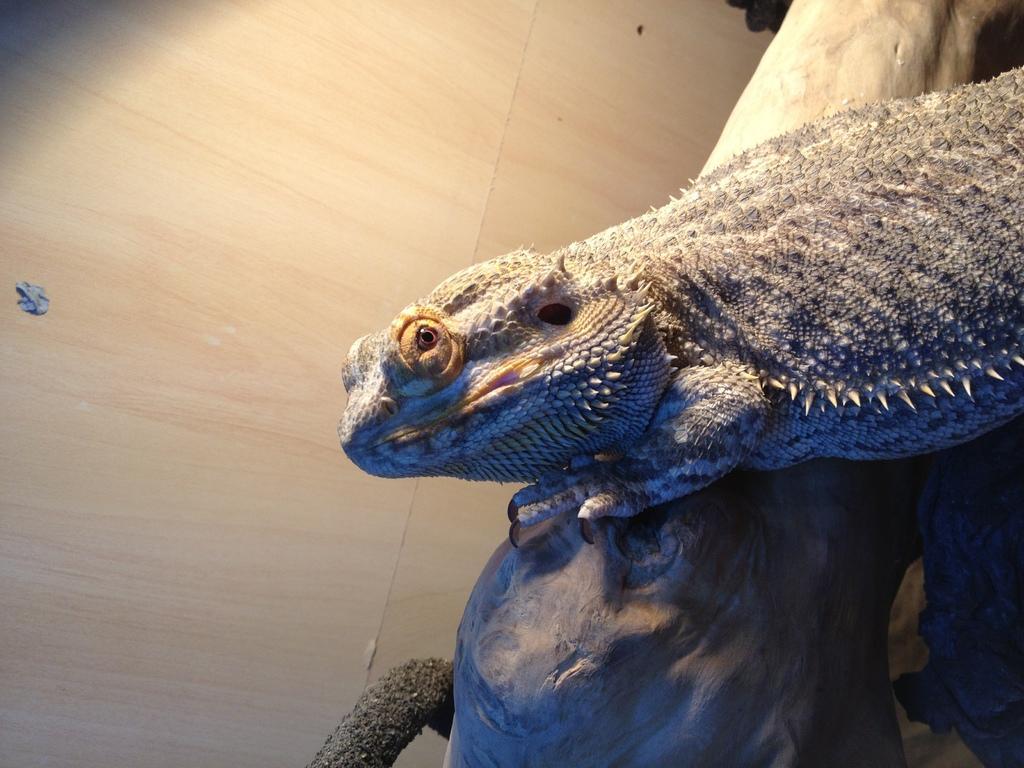How would you summarize this image in a sentence or two? On the right we can see a lizard on a log and this is a floor. 